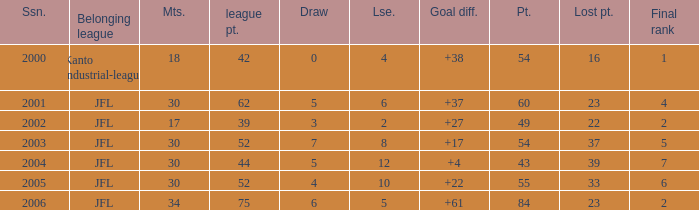Tell me the average final rank for loe more than 10 and point less than 43 None. 